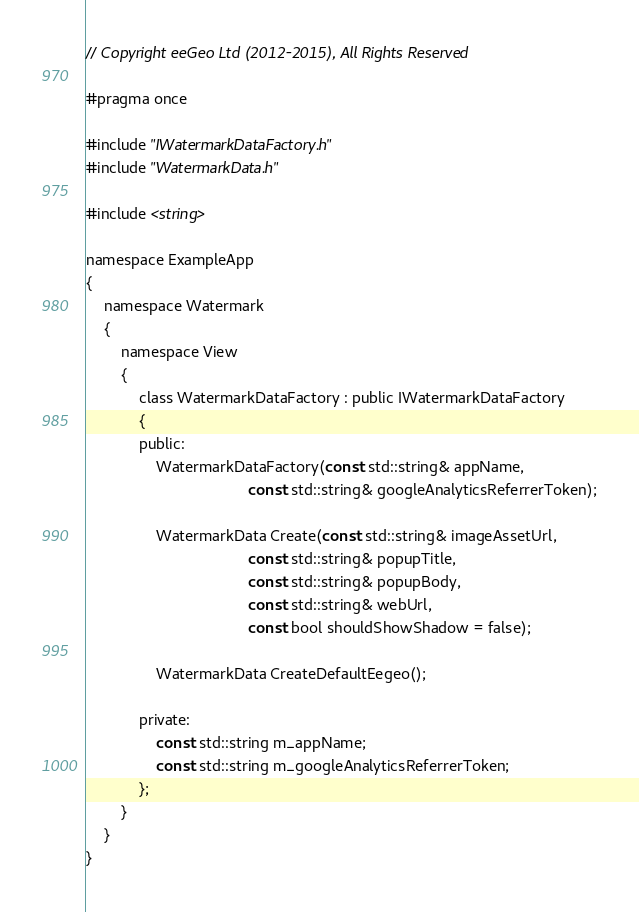Convert code to text. <code><loc_0><loc_0><loc_500><loc_500><_C_>// Copyright eeGeo Ltd (2012-2015), All Rights Reserved

#pragma once

#include "IWatermarkDataFactory.h"
#include "WatermarkData.h"

#include <string>

namespace ExampleApp
{
    namespace Watermark
    {
        namespace View
        {
            class WatermarkDataFactory : public IWatermarkDataFactory
            {
            public:
                WatermarkDataFactory(const std::string& appName,
                                     const std::string& googleAnalyticsReferrerToken);
                
                WatermarkData Create(const std::string& imageAssetUrl,
                                     const std::string& popupTitle,
                                     const std::string& popupBody,
                                     const std::string& webUrl,
                                     const bool shouldShowShadow = false);
                
                WatermarkData CreateDefaultEegeo();
                
            private:
                const std::string m_appName;
                const std::string m_googleAnalyticsReferrerToken;
            };
        }
    }
}</code> 